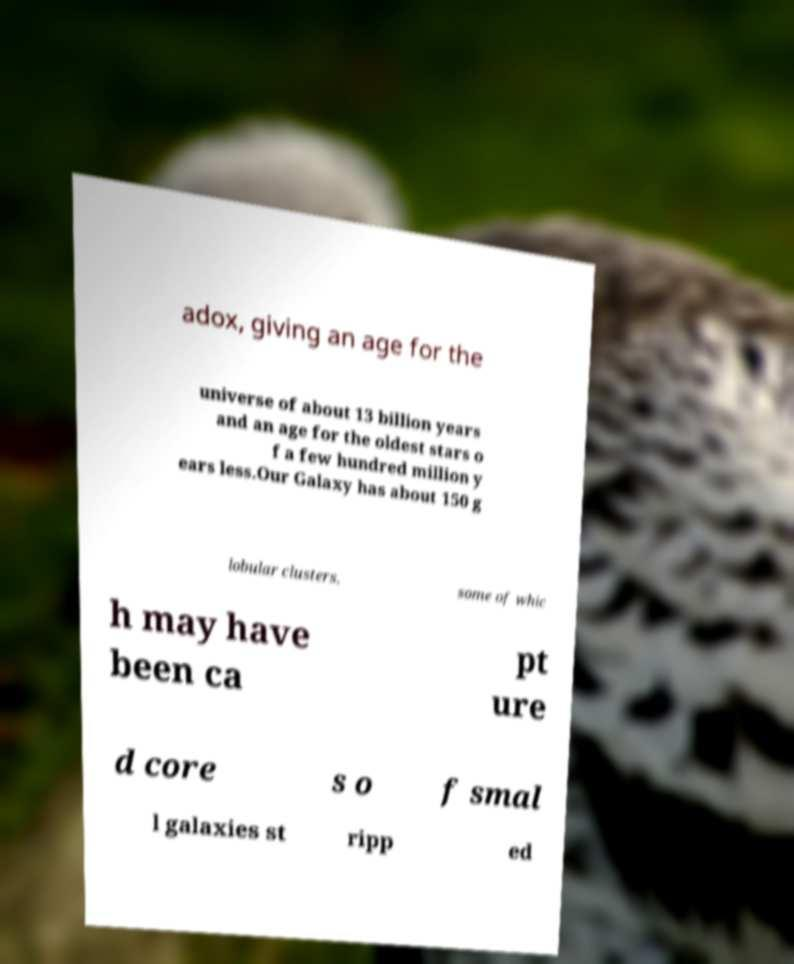For documentation purposes, I need the text within this image transcribed. Could you provide that? adox, giving an age for the universe of about 13 billion years and an age for the oldest stars o f a few hundred million y ears less.Our Galaxy has about 150 g lobular clusters, some of whic h may have been ca pt ure d core s o f smal l galaxies st ripp ed 